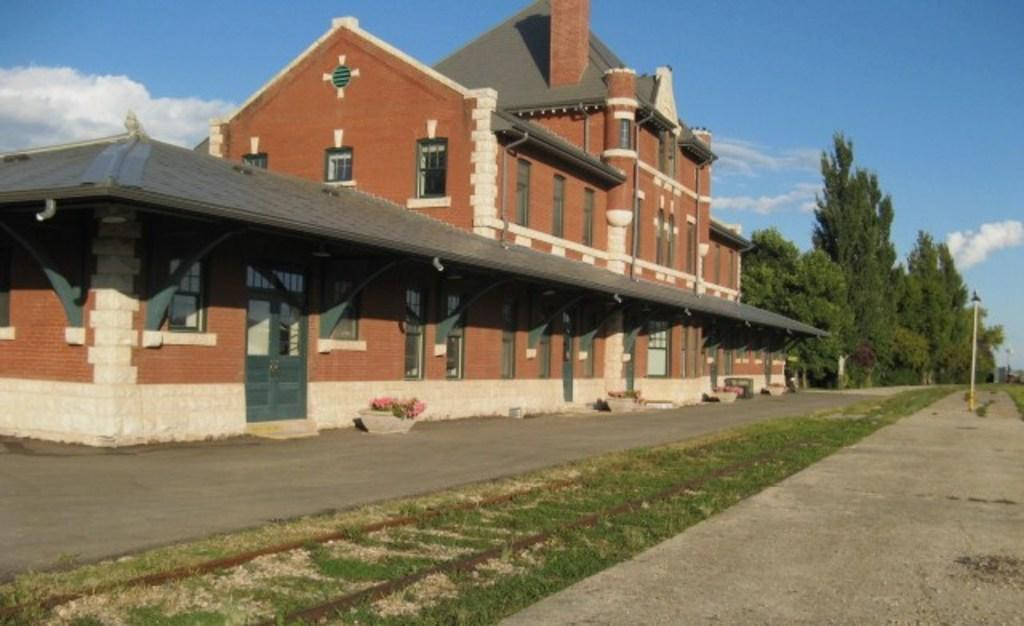What type of structure is visible in the image? There is a building in the image. What other natural elements can be seen in the image? There are trees in the image. What type of lighting is present in the image? There is a pole light in the image. Can you describe the transportation feature in the image? The image appears to show a rail track. What type of vegetation is present in the image? There are plants in pots in the image. How would you describe the sky in the image? The sky is blue and cloudy in the image. Where is the family sitting in the image? There is no family present in the image; it features a building, trees, a pole light, a rail track, plants in pots, and a blue and cloudy sky. What type of division is visible in the image? There is no division present in the image; it features a building, trees, a pole light, a rail track, plants in pots, and a blue and cloudy sky. 